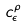<formula> <loc_0><loc_0><loc_500><loc_500>c _ { \epsilon } ^ { \rho }</formula> 